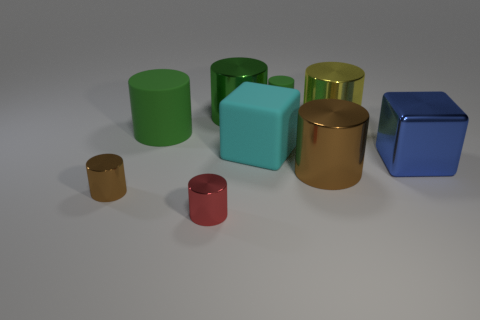How many green cylinders must be subtracted to get 1 green cylinders? 2 Subtract all green blocks. How many brown cylinders are left? 2 Subtract all small brown cylinders. How many cylinders are left? 6 Subtract 4 cylinders. How many cylinders are left? 3 Add 1 red objects. How many objects exist? 10 Subtract all green cylinders. How many cylinders are left? 4 Subtract all red cylinders. Subtract all red cubes. How many cylinders are left? 6 Add 4 cyan rubber things. How many cyan rubber things exist? 5 Subtract 0 purple cylinders. How many objects are left? 9 Subtract all cylinders. How many objects are left? 2 